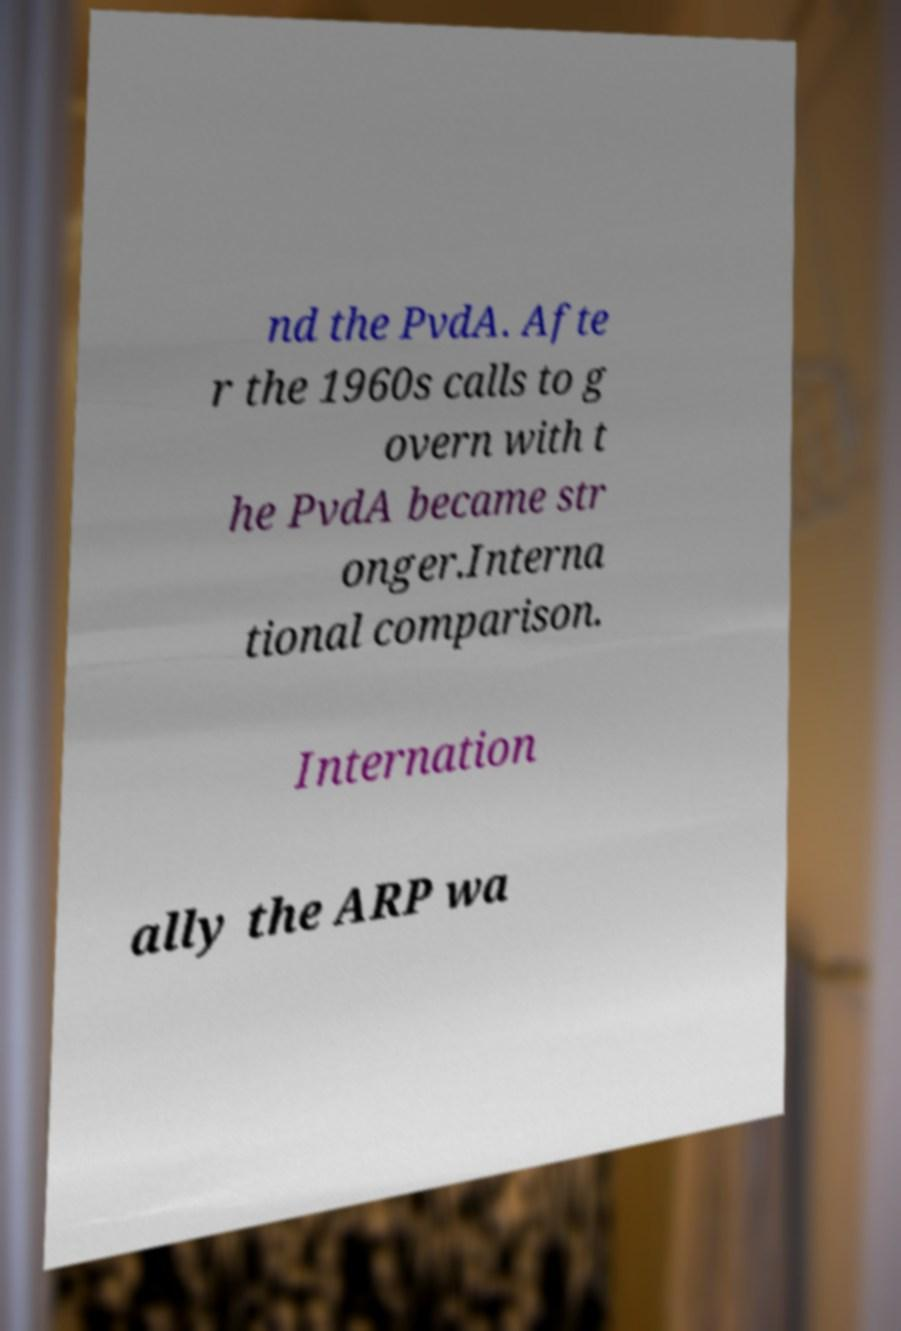Can you read and provide the text displayed in the image?This photo seems to have some interesting text. Can you extract and type it out for me? nd the PvdA. Afte r the 1960s calls to g overn with t he PvdA became str onger.Interna tional comparison. Internation ally the ARP wa 